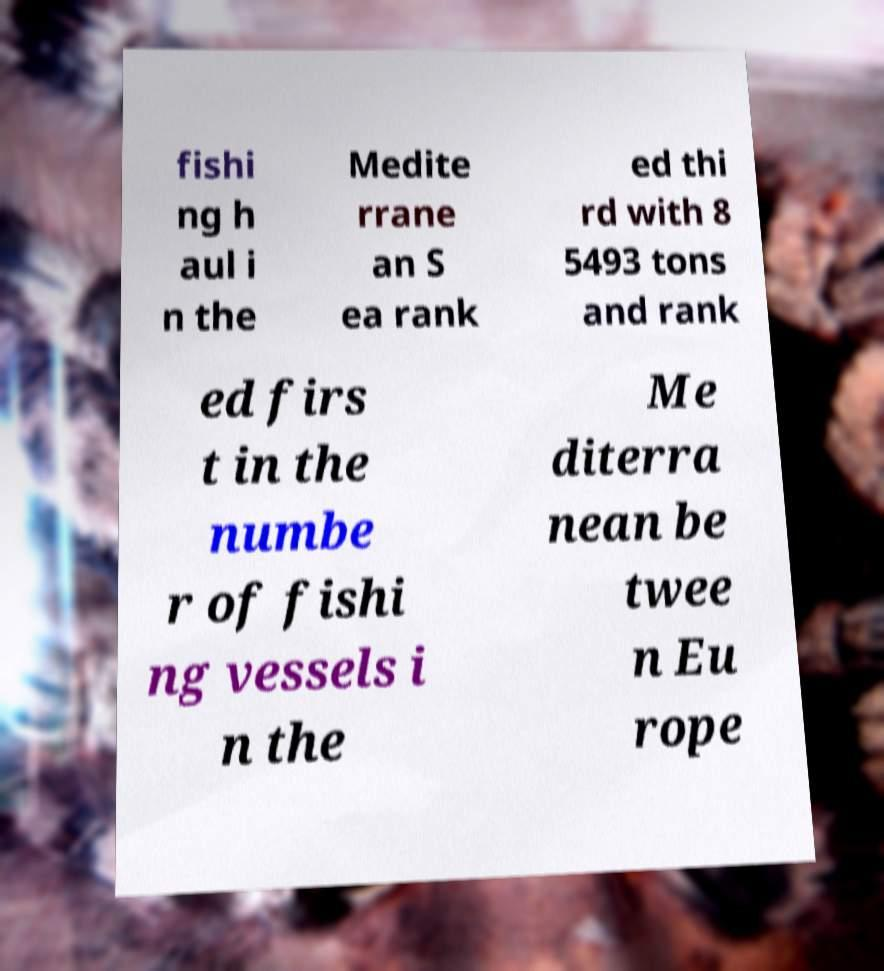Could you extract and type out the text from this image? fishi ng h aul i n the Medite rrane an S ea rank ed thi rd with 8 5493 tons and rank ed firs t in the numbe r of fishi ng vessels i n the Me diterra nean be twee n Eu rope 